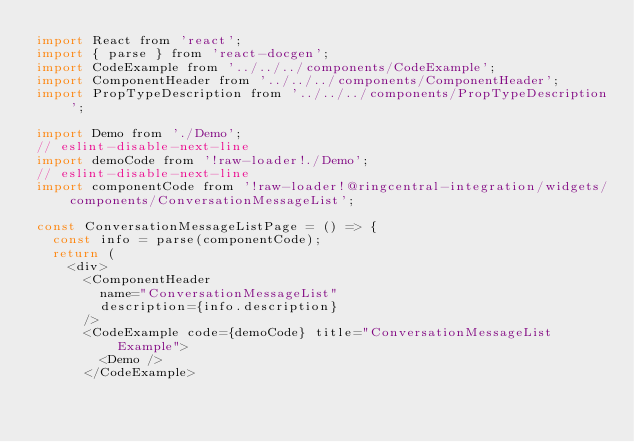Convert code to text. <code><loc_0><loc_0><loc_500><loc_500><_JavaScript_>import React from 'react';
import { parse } from 'react-docgen';
import CodeExample from '../../../components/CodeExample';
import ComponentHeader from '../../../components/ComponentHeader';
import PropTypeDescription from '../../../components/PropTypeDescription';

import Demo from './Demo';
// eslint-disable-next-line
import demoCode from '!raw-loader!./Demo';
// eslint-disable-next-line
import componentCode from '!raw-loader!@ringcentral-integration/widgets/components/ConversationMessageList';

const ConversationMessageListPage = () => {
  const info = parse(componentCode);
  return (
    <div>
      <ComponentHeader
        name="ConversationMessageList"
        description={info.description}
      />
      <CodeExample code={demoCode} title="ConversationMessageList Example">
        <Demo />
      </CodeExample></code> 